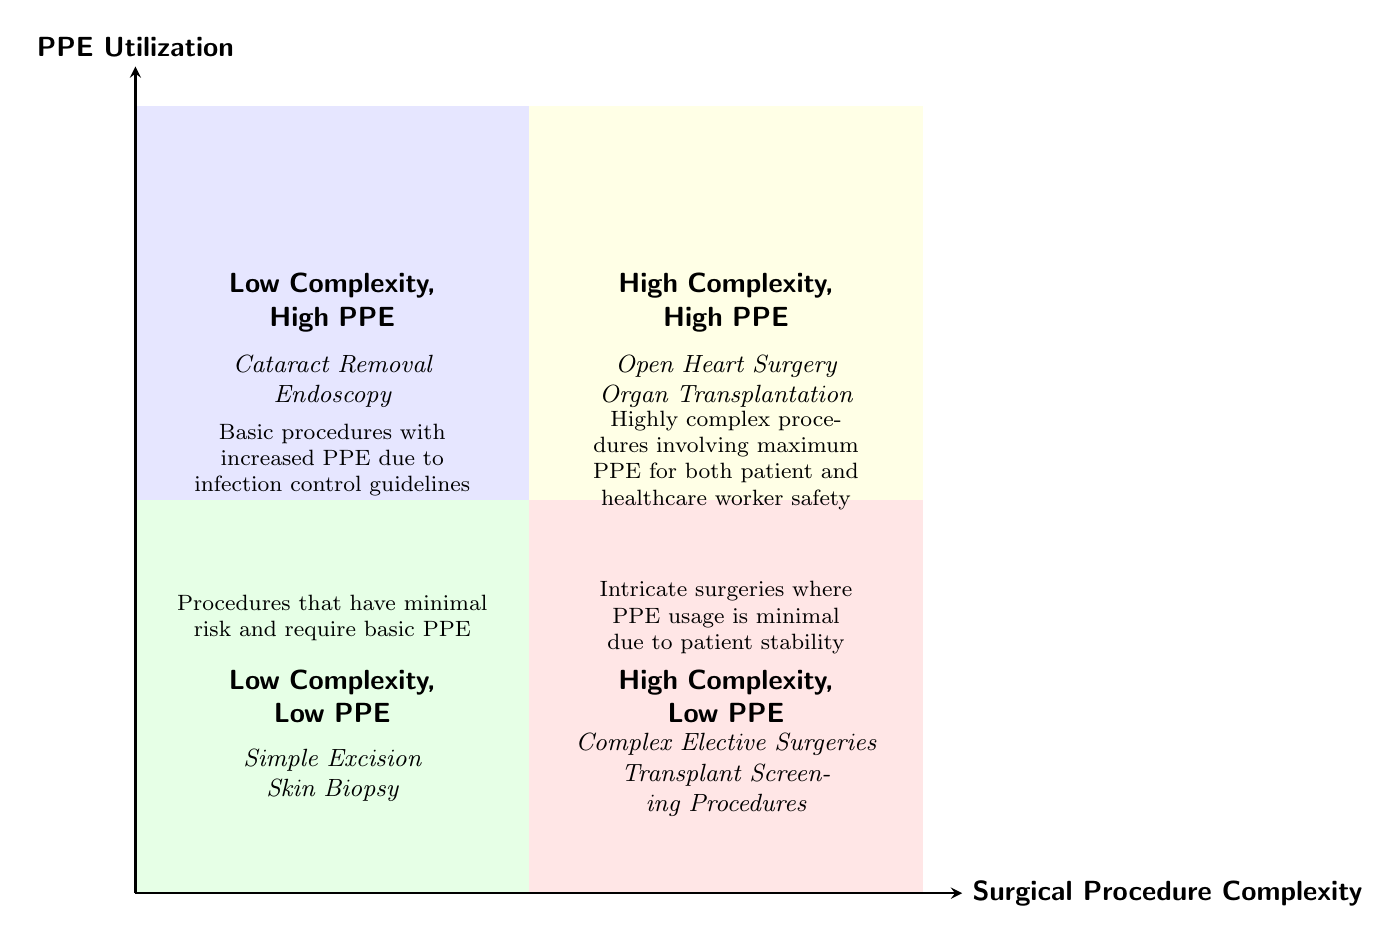What types of surgeries are listed in the "High Complexity, Low PPE" quadrant? In the "High Complexity, Low PPE" quadrant, the examples provided are "Complex Elective Surgeries" and "Transplant Screening Procedures." These types of surgeries fall under this specific category due to their intricate nature combined with lower PPE utilization.
Answer: Complex Elective Surgeries, Transplant Screening Procedures What is the description associated with "Low Complexity, High PPE"? The description for "Low Complexity, High PPE" explains that these are "Basic procedures with increased PPE due to infection control guidelines." It indicates that although the complexity is low, the risk of infection necessitates higher PPE use.
Answer: Basic procedures with increased PPE due to infection control guidelines How many quadrants does the diagram contain? The diagram contains four quadrants: "Low Complexity, Low PPE," "Low Complexity, High PPE," "High Complexity, Low PPE," and "High Complexity, High PPE." Each quadrant is distinct in the combination of complexity and PPE utilization.
Answer: Four Which quadrant involves the highest PPE utilization? The quadrant labeled "High Complexity, High PPE" involves the highest PPE utilization. This quadrant indicates that the procedures performed here are both complex and require maximum PPE for safety measures.
Answer: High Complexity, High PPE What is the relationship between surgical complexity and PPE utilization? The diagram suggests that as surgical complexity increases, so does the requirement for PPE, particularly in the case of "High Complexity, High PPE" procedures. In contrast, low complexity procedures may either utilize low or high PPE based on infection control measures.
Answer: As complexity increases, PPE utilization increases 